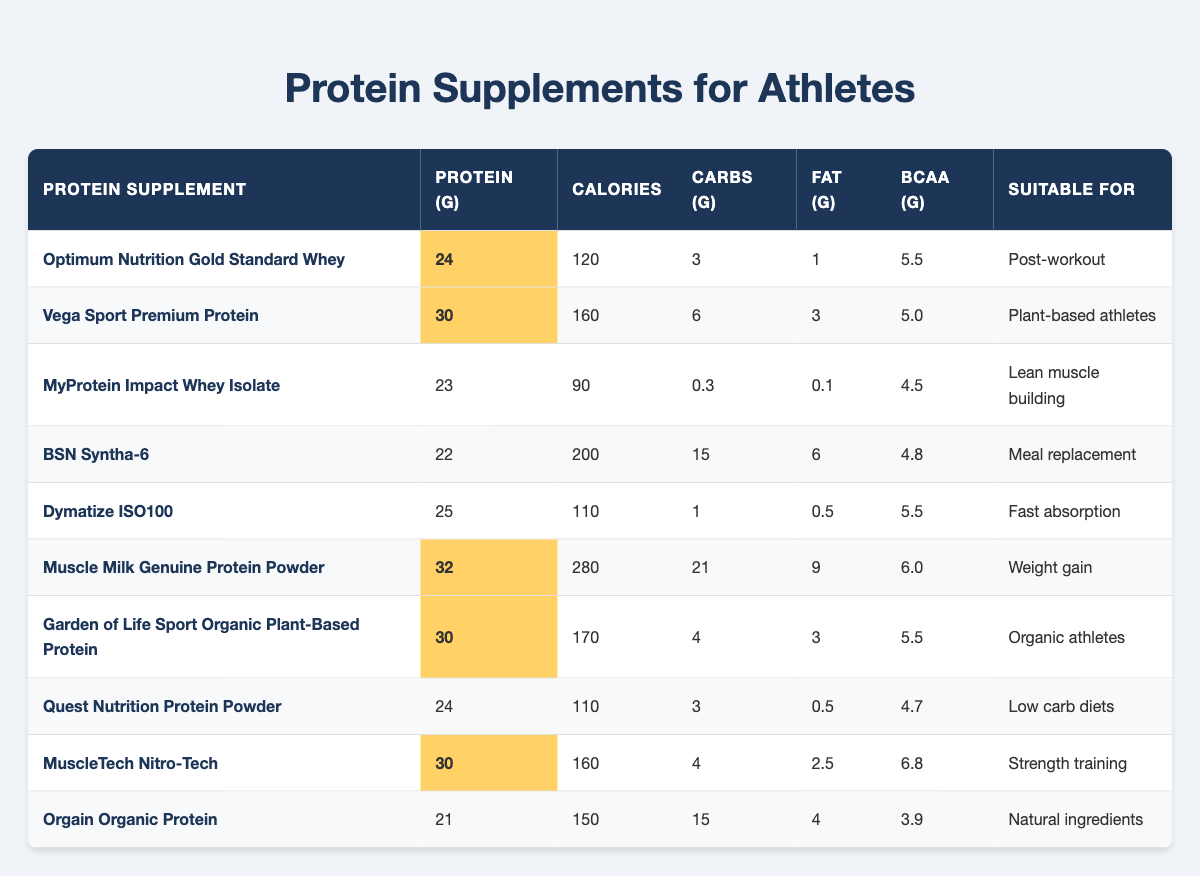What is the protein content of Muscle Milk Genuine Protein Powder? The table shows that the protein content for Muscle Milk Genuine Protein Powder is 32 grams.
Answer: 32 grams Which protein supplement has the lowest calorie count? By reviewing the calorie column, MyProtein Impact Whey Isolate has the lowest calorie count at 90 calories.
Answer: 90 calories Is Dymatize ISO100 suitable for weight gain? Dymatize ISO100 is listed as suitable for fast absorption, not specifically for weight gain, based on the "Suitable for" column, which indicates a focus on rapid intake rather than mass.
Answer: No What is the total protein content from the two highest protein supplements? The two highest protein supplements are Muscle Milk Genuine Protein Powder with 32 grams and Vega Sport Premium Protein with 30 grams. Summing them yields 32 + 30 = 62 grams.
Answer: 62 grams Are there any protein supplements that contain more than 5 grams of BCAA? Looking at the BCAA column, both MuscleTech Nitro-Tech (6.8 grams) and Muscle Milk Genuine Protein Powder (6.0 grams) have more than 5 grams of BCAA, confirming that there are multiple supplements that meet this criterion.
Answer: Yes Which supplement is meant for meal replacement? Referring to the "Suitable for" column, BSN Syntha-6 is explicitly listed as a meal replacement option.
Answer: BSN Syntha-6 What is the average carbohydrate content among the supplements suitable for low carb diets? The only supplement listed for low carb diets is Quest Nutrition Protein Powder, which has 3 grams of carbs. Since there is only one data point, the average is 3 grams.
Answer: 3 grams Which protein supplement has the highest fat content? By examining the fat content column, Muscle Milk Genuine Protein Powder has the highest fat content at 9 grams.
Answer: 9 grams What percentage of protein does Vega Sport Premium Protein represent in the subset of supplements over 25 grams of protein? The relevant supplements above 25 grams are Vega Sport Premium Protein (30g), Muscle Milk Genuine Protein Powder (32g), and MuscleTech Nitro-Tech (30g). The total protein from these three is 30 + 32 + 30 = 92 grams. Vega Sport’s protein share is 30/92, which is approximately 32.61%.
Answer: 32.61% 